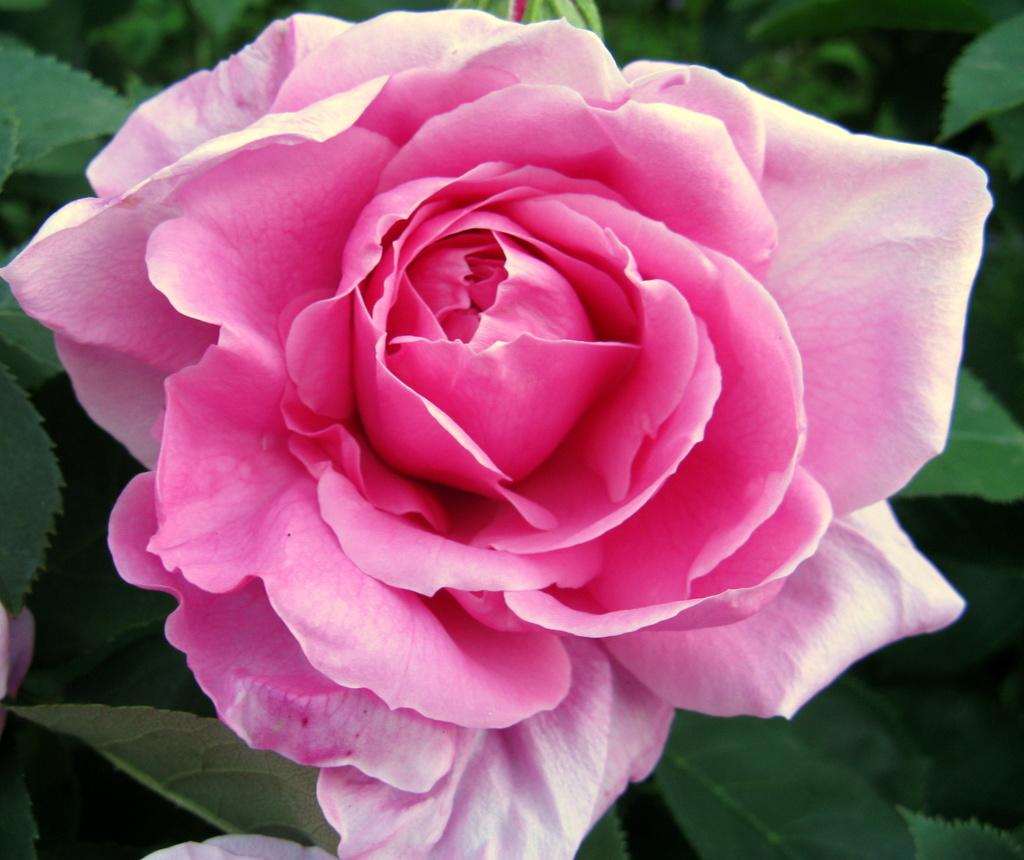What color is the rose in the image? The rose in the image is pink. Where is the rose located? The rose is on a plant in the image. Are there any other parts of the plant visible in the image? Yes, there is a bud on the plant in the image. What type of creature is holding the rose in the image? There is no creature present in the image; the rose is on a plant. Can you describe the arm of the person holding the rose in the image? There is no person or arm visible in the image; it only features a pink rose on a plant. 